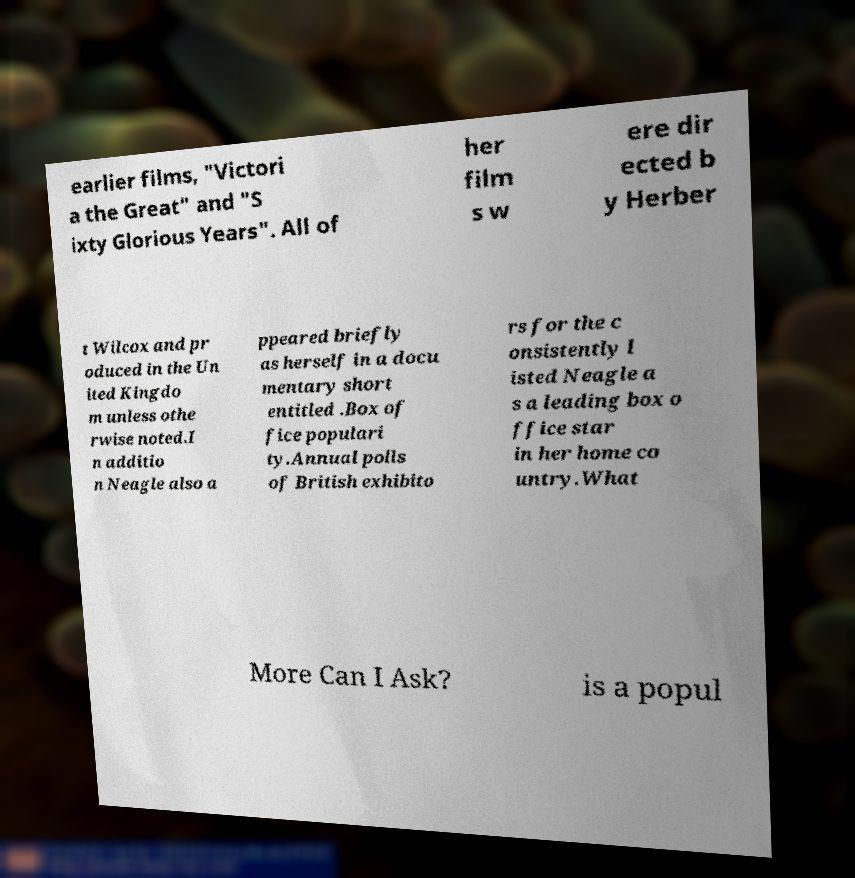Can you accurately transcribe the text from the provided image for me? earlier films, "Victori a the Great" and "S ixty Glorious Years". All of her film s w ere dir ected b y Herber t Wilcox and pr oduced in the Un ited Kingdo m unless othe rwise noted.I n additio n Neagle also a ppeared briefly as herself in a docu mentary short entitled .Box of fice populari ty.Annual polls of British exhibito rs for the c onsistently l isted Neagle a s a leading box o ffice star in her home co untry.What More Can I Ask? is a popul 